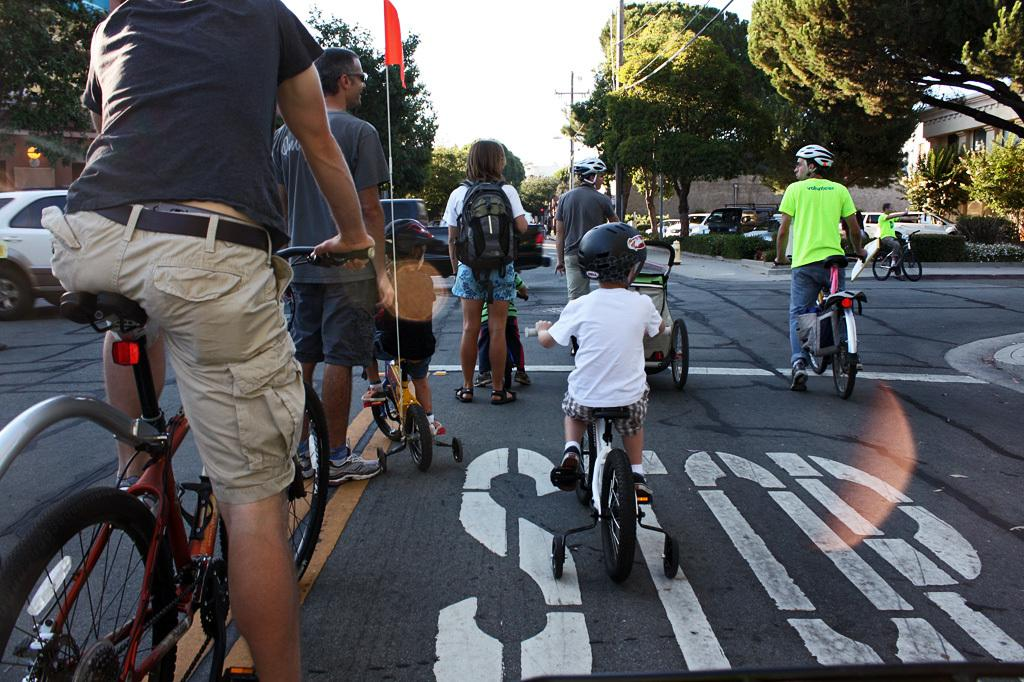How many people are in the image? There is a group of people in the image. What are the people wearing on their heads? Some of the people are wearing helmets. What are the people doing in the image? The people are riding bicycles. Where are the bicycles located? The bicycles are on roads. What can be seen in the background of the image? There are trees, a wall, cars, and the sky visible in the background of the image. What type of pies can be seen in the image? There are no pies present in the image. Can you tell me where the airport is located in the image? There is no airport present in the image. 